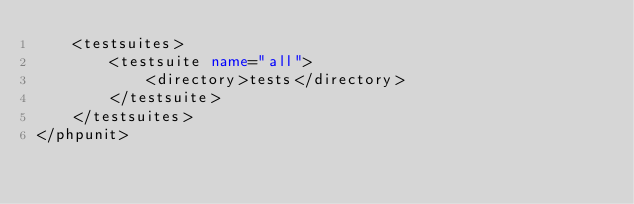Convert code to text. <code><loc_0><loc_0><loc_500><loc_500><_XML_>    <testsuites>
        <testsuite name="all">
            <directory>tests</directory>
        </testsuite>
    </testsuites>
</phpunit></code> 